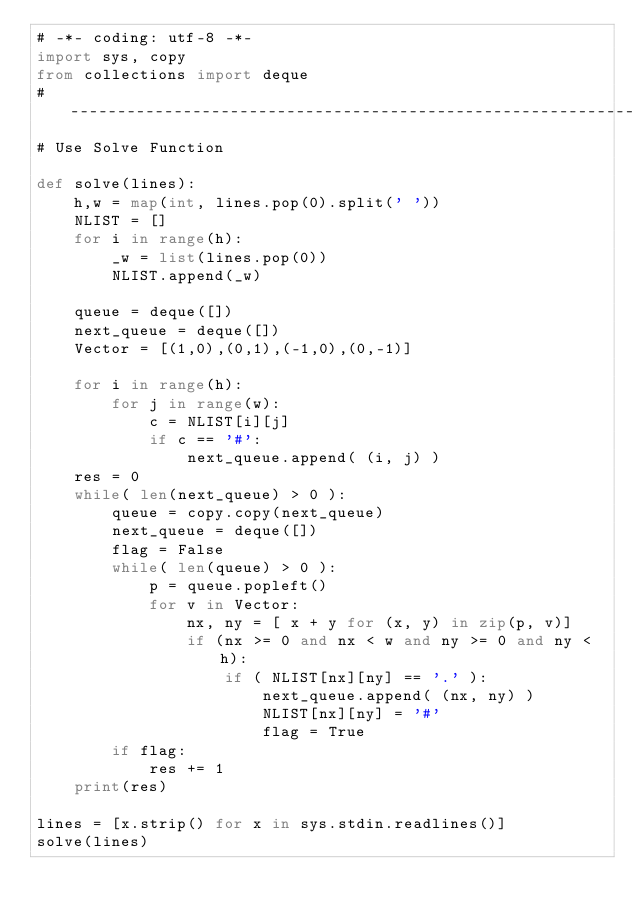<code> <loc_0><loc_0><loc_500><loc_500><_Python_># -*- coding: utf-8 -*-                                                                                  
import sys, copy                                                                                         
from collections import deque                                                                            
# ----------------------------------------------------------------                                       
# Use Solve Function                                                                                     
                                                                                                         
def solve(lines):                                                                                        
    h,w = map(int, lines.pop(0).split(' '))                                                              
    NLIST = []                                                                                           
    for i in range(h):                                                                                   
        _w = list(lines.pop(0))                                                                          
        NLIST.append(_w)                                                                                 
                                                                                                         
    queue = deque([])                                                                                    
    next_queue = deque([])                                                                               
    Vector = [(1,0),(0,1),(-1,0),(0,-1)]                                                                 
                                                                                                         
    for i in range(h):                                                                                   
        for j in range(w):                                                                               
            c = NLIST[i][j]                                                                              
            if c == '#':                                                                                 
                next_queue.append( (i, j) )                                                              
    res = 0                                                                                              
    while( len(next_queue) > 0 ):                                                                        
        queue = copy.copy(next_queue)                                                                    
        next_queue = deque([])                                                                           
        flag = False                                                                                     
        while( len(queue) > 0 ):                                                                         
            p = queue.popleft()                                                                          
            for v in Vector:                                                                             
                nx, ny = [ x + y for (x, y) in zip(p, v)]                                                
                if (nx >= 0 and nx < w and ny >= 0 and ny < h):                                          
                    if ( NLIST[nx][ny] == '.' ):                                                         
                        next_queue.append( (nx, ny) )                                                    
                        NLIST[nx][ny] = '#'                                                              
                        flag = True                                                                      
        if flag:                                                                                         
            res += 1                                                                                     
    print(res)                                                                                           
                                                                                                         
lines = [x.strip() for x in sys.stdin.readlines()]                                                       
solve(lines) </code> 